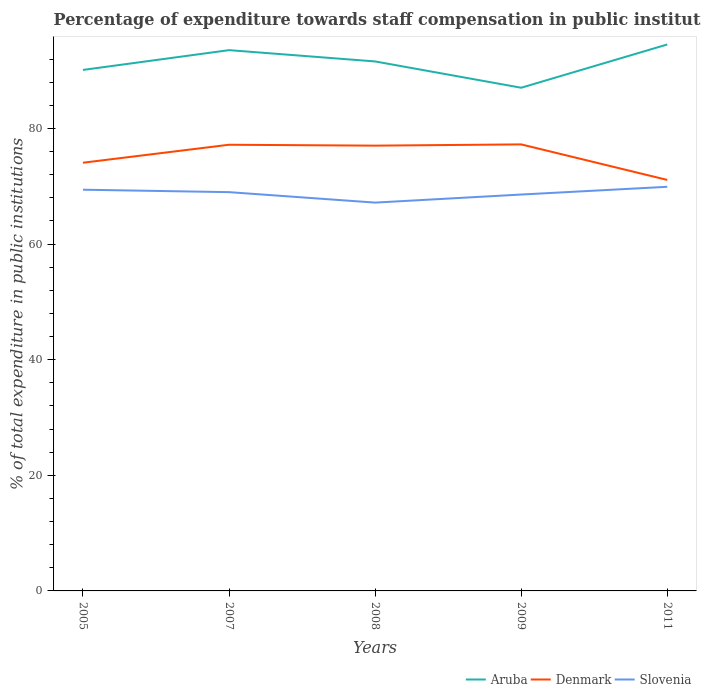Is the number of lines equal to the number of legend labels?
Keep it short and to the point. Yes. Across all years, what is the maximum percentage of expenditure towards staff compensation in Denmark?
Keep it short and to the point. 71.09. What is the total percentage of expenditure towards staff compensation in Denmark in the graph?
Your response must be concise. 0.15. What is the difference between the highest and the second highest percentage of expenditure towards staff compensation in Aruba?
Offer a very short reply. 7.48. What is the difference between the highest and the lowest percentage of expenditure towards staff compensation in Aruba?
Your answer should be very brief. 3. Is the percentage of expenditure towards staff compensation in Aruba strictly greater than the percentage of expenditure towards staff compensation in Slovenia over the years?
Give a very brief answer. No. How many lines are there?
Give a very brief answer. 3. Does the graph contain any zero values?
Give a very brief answer. No. Does the graph contain grids?
Your response must be concise. No. What is the title of the graph?
Make the answer very short. Percentage of expenditure towards staff compensation in public institutions. What is the label or title of the Y-axis?
Provide a succinct answer. % of total expenditure in public institutions. What is the % of total expenditure in public institutions in Aruba in 2005?
Your answer should be compact. 90.11. What is the % of total expenditure in public institutions of Denmark in 2005?
Your response must be concise. 74.06. What is the % of total expenditure in public institutions of Slovenia in 2005?
Your answer should be very brief. 69.39. What is the % of total expenditure in public institutions in Aruba in 2007?
Provide a succinct answer. 93.53. What is the % of total expenditure in public institutions in Denmark in 2007?
Your answer should be very brief. 77.17. What is the % of total expenditure in public institutions in Slovenia in 2007?
Keep it short and to the point. 68.97. What is the % of total expenditure in public institutions of Aruba in 2008?
Ensure brevity in your answer.  91.58. What is the % of total expenditure in public institutions in Denmark in 2008?
Your answer should be compact. 77.02. What is the % of total expenditure in public institutions of Slovenia in 2008?
Your answer should be compact. 67.16. What is the % of total expenditure in public institutions of Aruba in 2009?
Keep it short and to the point. 87.03. What is the % of total expenditure in public institutions of Denmark in 2009?
Make the answer very short. 77.23. What is the % of total expenditure in public institutions in Slovenia in 2009?
Your answer should be very brief. 68.56. What is the % of total expenditure in public institutions of Aruba in 2011?
Provide a short and direct response. 94.51. What is the % of total expenditure in public institutions in Denmark in 2011?
Make the answer very short. 71.09. What is the % of total expenditure in public institutions of Slovenia in 2011?
Your answer should be compact. 69.9. Across all years, what is the maximum % of total expenditure in public institutions in Aruba?
Make the answer very short. 94.51. Across all years, what is the maximum % of total expenditure in public institutions of Denmark?
Make the answer very short. 77.23. Across all years, what is the maximum % of total expenditure in public institutions in Slovenia?
Give a very brief answer. 69.9. Across all years, what is the minimum % of total expenditure in public institutions in Aruba?
Keep it short and to the point. 87.03. Across all years, what is the minimum % of total expenditure in public institutions in Denmark?
Offer a terse response. 71.09. Across all years, what is the minimum % of total expenditure in public institutions in Slovenia?
Offer a terse response. 67.16. What is the total % of total expenditure in public institutions in Aruba in the graph?
Keep it short and to the point. 456.77. What is the total % of total expenditure in public institutions in Denmark in the graph?
Ensure brevity in your answer.  376.57. What is the total % of total expenditure in public institutions in Slovenia in the graph?
Give a very brief answer. 343.99. What is the difference between the % of total expenditure in public institutions in Aruba in 2005 and that in 2007?
Your answer should be compact. -3.42. What is the difference between the % of total expenditure in public institutions of Denmark in 2005 and that in 2007?
Your response must be concise. -3.11. What is the difference between the % of total expenditure in public institutions in Slovenia in 2005 and that in 2007?
Give a very brief answer. 0.42. What is the difference between the % of total expenditure in public institutions of Aruba in 2005 and that in 2008?
Provide a succinct answer. -1.47. What is the difference between the % of total expenditure in public institutions of Denmark in 2005 and that in 2008?
Offer a very short reply. -2.96. What is the difference between the % of total expenditure in public institutions in Slovenia in 2005 and that in 2008?
Offer a terse response. 2.23. What is the difference between the % of total expenditure in public institutions of Aruba in 2005 and that in 2009?
Offer a terse response. 3.08. What is the difference between the % of total expenditure in public institutions of Denmark in 2005 and that in 2009?
Ensure brevity in your answer.  -3.17. What is the difference between the % of total expenditure in public institutions in Slovenia in 2005 and that in 2009?
Ensure brevity in your answer.  0.83. What is the difference between the % of total expenditure in public institutions of Aruba in 2005 and that in 2011?
Give a very brief answer. -4.4. What is the difference between the % of total expenditure in public institutions in Denmark in 2005 and that in 2011?
Ensure brevity in your answer.  2.98. What is the difference between the % of total expenditure in public institutions in Slovenia in 2005 and that in 2011?
Ensure brevity in your answer.  -0.5. What is the difference between the % of total expenditure in public institutions in Aruba in 2007 and that in 2008?
Make the answer very short. 1.95. What is the difference between the % of total expenditure in public institutions of Denmark in 2007 and that in 2008?
Give a very brief answer. 0.15. What is the difference between the % of total expenditure in public institutions in Slovenia in 2007 and that in 2008?
Ensure brevity in your answer.  1.81. What is the difference between the % of total expenditure in public institutions in Aruba in 2007 and that in 2009?
Offer a terse response. 6.5. What is the difference between the % of total expenditure in public institutions in Denmark in 2007 and that in 2009?
Your answer should be very brief. -0.06. What is the difference between the % of total expenditure in public institutions in Slovenia in 2007 and that in 2009?
Make the answer very short. 0.41. What is the difference between the % of total expenditure in public institutions in Aruba in 2007 and that in 2011?
Your response must be concise. -0.98. What is the difference between the % of total expenditure in public institutions in Denmark in 2007 and that in 2011?
Give a very brief answer. 6.08. What is the difference between the % of total expenditure in public institutions of Slovenia in 2007 and that in 2011?
Your answer should be compact. -0.92. What is the difference between the % of total expenditure in public institutions of Aruba in 2008 and that in 2009?
Offer a very short reply. 4.55. What is the difference between the % of total expenditure in public institutions of Denmark in 2008 and that in 2009?
Make the answer very short. -0.21. What is the difference between the % of total expenditure in public institutions in Slovenia in 2008 and that in 2009?
Keep it short and to the point. -1.4. What is the difference between the % of total expenditure in public institutions in Aruba in 2008 and that in 2011?
Provide a succinct answer. -2.93. What is the difference between the % of total expenditure in public institutions in Denmark in 2008 and that in 2011?
Keep it short and to the point. 5.93. What is the difference between the % of total expenditure in public institutions of Slovenia in 2008 and that in 2011?
Your response must be concise. -2.73. What is the difference between the % of total expenditure in public institutions of Aruba in 2009 and that in 2011?
Provide a succinct answer. -7.48. What is the difference between the % of total expenditure in public institutions of Denmark in 2009 and that in 2011?
Provide a short and direct response. 6.15. What is the difference between the % of total expenditure in public institutions of Slovenia in 2009 and that in 2011?
Provide a short and direct response. -1.34. What is the difference between the % of total expenditure in public institutions in Aruba in 2005 and the % of total expenditure in public institutions in Denmark in 2007?
Keep it short and to the point. 12.94. What is the difference between the % of total expenditure in public institutions in Aruba in 2005 and the % of total expenditure in public institutions in Slovenia in 2007?
Provide a short and direct response. 21.14. What is the difference between the % of total expenditure in public institutions in Denmark in 2005 and the % of total expenditure in public institutions in Slovenia in 2007?
Your response must be concise. 5.09. What is the difference between the % of total expenditure in public institutions in Aruba in 2005 and the % of total expenditure in public institutions in Denmark in 2008?
Ensure brevity in your answer.  13.09. What is the difference between the % of total expenditure in public institutions in Aruba in 2005 and the % of total expenditure in public institutions in Slovenia in 2008?
Provide a short and direct response. 22.95. What is the difference between the % of total expenditure in public institutions in Denmark in 2005 and the % of total expenditure in public institutions in Slovenia in 2008?
Your answer should be very brief. 6.9. What is the difference between the % of total expenditure in public institutions of Aruba in 2005 and the % of total expenditure in public institutions of Denmark in 2009?
Give a very brief answer. 12.88. What is the difference between the % of total expenditure in public institutions in Aruba in 2005 and the % of total expenditure in public institutions in Slovenia in 2009?
Your answer should be very brief. 21.55. What is the difference between the % of total expenditure in public institutions in Denmark in 2005 and the % of total expenditure in public institutions in Slovenia in 2009?
Offer a very short reply. 5.5. What is the difference between the % of total expenditure in public institutions in Aruba in 2005 and the % of total expenditure in public institutions in Denmark in 2011?
Your answer should be very brief. 19.03. What is the difference between the % of total expenditure in public institutions in Aruba in 2005 and the % of total expenditure in public institutions in Slovenia in 2011?
Offer a very short reply. 20.21. What is the difference between the % of total expenditure in public institutions of Denmark in 2005 and the % of total expenditure in public institutions of Slovenia in 2011?
Make the answer very short. 4.16. What is the difference between the % of total expenditure in public institutions of Aruba in 2007 and the % of total expenditure in public institutions of Denmark in 2008?
Provide a short and direct response. 16.52. What is the difference between the % of total expenditure in public institutions in Aruba in 2007 and the % of total expenditure in public institutions in Slovenia in 2008?
Your answer should be very brief. 26.37. What is the difference between the % of total expenditure in public institutions in Denmark in 2007 and the % of total expenditure in public institutions in Slovenia in 2008?
Provide a short and direct response. 10.01. What is the difference between the % of total expenditure in public institutions of Aruba in 2007 and the % of total expenditure in public institutions of Denmark in 2009?
Your answer should be very brief. 16.3. What is the difference between the % of total expenditure in public institutions of Aruba in 2007 and the % of total expenditure in public institutions of Slovenia in 2009?
Your answer should be compact. 24.97. What is the difference between the % of total expenditure in public institutions in Denmark in 2007 and the % of total expenditure in public institutions in Slovenia in 2009?
Provide a short and direct response. 8.61. What is the difference between the % of total expenditure in public institutions in Aruba in 2007 and the % of total expenditure in public institutions in Denmark in 2011?
Ensure brevity in your answer.  22.45. What is the difference between the % of total expenditure in public institutions in Aruba in 2007 and the % of total expenditure in public institutions in Slovenia in 2011?
Keep it short and to the point. 23.64. What is the difference between the % of total expenditure in public institutions of Denmark in 2007 and the % of total expenditure in public institutions of Slovenia in 2011?
Offer a very short reply. 7.27. What is the difference between the % of total expenditure in public institutions of Aruba in 2008 and the % of total expenditure in public institutions of Denmark in 2009?
Provide a succinct answer. 14.35. What is the difference between the % of total expenditure in public institutions of Aruba in 2008 and the % of total expenditure in public institutions of Slovenia in 2009?
Your response must be concise. 23.02. What is the difference between the % of total expenditure in public institutions of Denmark in 2008 and the % of total expenditure in public institutions of Slovenia in 2009?
Offer a terse response. 8.46. What is the difference between the % of total expenditure in public institutions in Aruba in 2008 and the % of total expenditure in public institutions in Denmark in 2011?
Make the answer very short. 20.49. What is the difference between the % of total expenditure in public institutions of Aruba in 2008 and the % of total expenditure in public institutions of Slovenia in 2011?
Provide a short and direct response. 21.68. What is the difference between the % of total expenditure in public institutions of Denmark in 2008 and the % of total expenditure in public institutions of Slovenia in 2011?
Provide a succinct answer. 7.12. What is the difference between the % of total expenditure in public institutions in Aruba in 2009 and the % of total expenditure in public institutions in Denmark in 2011?
Offer a terse response. 15.95. What is the difference between the % of total expenditure in public institutions in Aruba in 2009 and the % of total expenditure in public institutions in Slovenia in 2011?
Your response must be concise. 17.13. What is the difference between the % of total expenditure in public institutions of Denmark in 2009 and the % of total expenditure in public institutions of Slovenia in 2011?
Make the answer very short. 7.33. What is the average % of total expenditure in public institutions in Aruba per year?
Offer a very short reply. 91.35. What is the average % of total expenditure in public institutions in Denmark per year?
Ensure brevity in your answer.  75.31. What is the average % of total expenditure in public institutions of Slovenia per year?
Your response must be concise. 68.8. In the year 2005, what is the difference between the % of total expenditure in public institutions in Aruba and % of total expenditure in public institutions in Denmark?
Give a very brief answer. 16.05. In the year 2005, what is the difference between the % of total expenditure in public institutions in Aruba and % of total expenditure in public institutions in Slovenia?
Offer a terse response. 20.72. In the year 2005, what is the difference between the % of total expenditure in public institutions in Denmark and % of total expenditure in public institutions in Slovenia?
Keep it short and to the point. 4.67. In the year 2007, what is the difference between the % of total expenditure in public institutions of Aruba and % of total expenditure in public institutions of Denmark?
Your response must be concise. 16.36. In the year 2007, what is the difference between the % of total expenditure in public institutions of Aruba and % of total expenditure in public institutions of Slovenia?
Provide a short and direct response. 24.56. In the year 2007, what is the difference between the % of total expenditure in public institutions of Denmark and % of total expenditure in public institutions of Slovenia?
Your answer should be compact. 8.2. In the year 2008, what is the difference between the % of total expenditure in public institutions of Aruba and % of total expenditure in public institutions of Denmark?
Provide a succinct answer. 14.56. In the year 2008, what is the difference between the % of total expenditure in public institutions of Aruba and % of total expenditure in public institutions of Slovenia?
Ensure brevity in your answer.  24.42. In the year 2008, what is the difference between the % of total expenditure in public institutions of Denmark and % of total expenditure in public institutions of Slovenia?
Provide a succinct answer. 9.85. In the year 2009, what is the difference between the % of total expenditure in public institutions in Aruba and % of total expenditure in public institutions in Denmark?
Give a very brief answer. 9.8. In the year 2009, what is the difference between the % of total expenditure in public institutions of Aruba and % of total expenditure in public institutions of Slovenia?
Your answer should be very brief. 18.47. In the year 2009, what is the difference between the % of total expenditure in public institutions in Denmark and % of total expenditure in public institutions in Slovenia?
Offer a very short reply. 8.67. In the year 2011, what is the difference between the % of total expenditure in public institutions of Aruba and % of total expenditure in public institutions of Denmark?
Your answer should be compact. 23.43. In the year 2011, what is the difference between the % of total expenditure in public institutions in Aruba and % of total expenditure in public institutions in Slovenia?
Your response must be concise. 24.62. In the year 2011, what is the difference between the % of total expenditure in public institutions of Denmark and % of total expenditure in public institutions of Slovenia?
Offer a terse response. 1.19. What is the ratio of the % of total expenditure in public institutions of Aruba in 2005 to that in 2007?
Your response must be concise. 0.96. What is the ratio of the % of total expenditure in public institutions in Denmark in 2005 to that in 2007?
Provide a succinct answer. 0.96. What is the ratio of the % of total expenditure in public institutions in Slovenia in 2005 to that in 2007?
Keep it short and to the point. 1.01. What is the ratio of the % of total expenditure in public institutions of Aruba in 2005 to that in 2008?
Offer a terse response. 0.98. What is the ratio of the % of total expenditure in public institutions in Denmark in 2005 to that in 2008?
Offer a very short reply. 0.96. What is the ratio of the % of total expenditure in public institutions in Slovenia in 2005 to that in 2008?
Give a very brief answer. 1.03. What is the ratio of the % of total expenditure in public institutions in Aruba in 2005 to that in 2009?
Your response must be concise. 1.04. What is the ratio of the % of total expenditure in public institutions in Denmark in 2005 to that in 2009?
Provide a succinct answer. 0.96. What is the ratio of the % of total expenditure in public institutions of Slovenia in 2005 to that in 2009?
Your answer should be compact. 1.01. What is the ratio of the % of total expenditure in public institutions in Aruba in 2005 to that in 2011?
Offer a terse response. 0.95. What is the ratio of the % of total expenditure in public institutions of Denmark in 2005 to that in 2011?
Your response must be concise. 1.04. What is the ratio of the % of total expenditure in public institutions of Slovenia in 2005 to that in 2011?
Ensure brevity in your answer.  0.99. What is the ratio of the % of total expenditure in public institutions in Aruba in 2007 to that in 2008?
Provide a short and direct response. 1.02. What is the ratio of the % of total expenditure in public institutions in Denmark in 2007 to that in 2008?
Give a very brief answer. 1. What is the ratio of the % of total expenditure in public institutions of Aruba in 2007 to that in 2009?
Keep it short and to the point. 1.07. What is the ratio of the % of total expenditure in public institutions of Slovenia in 2007 to that in 2009?
Your response must be concise. 1.01. What is the ratio of the % of total expenditure in public institutions of Aruba in 2007 to that in 2011?
Provide a succinct answer. 0.99. What is the ratio of the % of total expenditure in public institutions of Denmark in 2007 to that in 2011?
Make the answer very short. 1.09. What is the ratio of the % of total expenditure in public institutions in Slovenia in 2007 to that in 2011?
Give a very brief answer. 0.99. What is the ratio of the % of total expenditure in public institutions in Aruba in 2008 to that in 2009?
Give a very brief answer. 1.05. What is the ratio of the % of total expenditure in public institutions in Denmark in 2008 to that in 2009?
Your response must be concise. 1. What is the ratio of the % of total expenditure in public institutions of Slovenia in 2008 to that in 2009?
Offer a very short reply. 0.98. What is the ratio of the % of total expenditure in public institutions of Denmark in 2008 to that in 2011?
Keep it short and to the point. 1.08. What is the ratio of the % of total expenditure in public institutions of Slovenia in 2008 to that in 2011?
Provide a short and direct response. 0.96. What is the ratio of the % of total expenditure in public institutions of Aruba in 2009 to that in 2011?
Offer a terse response. 0.92. What is the ratio of the % of total expenditure in public institutions in Denmark in 2009 to that in 2011?
Offer a terse response. 1.09. What is the ratio of the % of total expenditure in public institutions in Slovenia in 2009 to that in 2011?
Give a very brief answer. 0.98. What is the difference between the highest and the second highest % of total expenditure in public institutions in Aruba?
Give a very brief answer. 0.98. What is the difference between the highest and the second highest % of total expenditure in public institutions in Denmark?
Provide a succinct answer. 0.06. What is the difference between the highest and the second highest % of total expenditure in public institutions of Slovenia?
Your answer should be very brief. 0.5. What is the difference between the highest and the lowest % of total expenditure in public institutions of Aruba?
Offer a terse response. 7.48. What is the difference between the highest and the lowest % of total expenditure in public institutions of Denmark?
Offer a very short reply. 6.15. What is the difference between the highest and the lowest % of total expenditure in public institutions in Slovenia?
Provide a succinct answer. 2.73. 